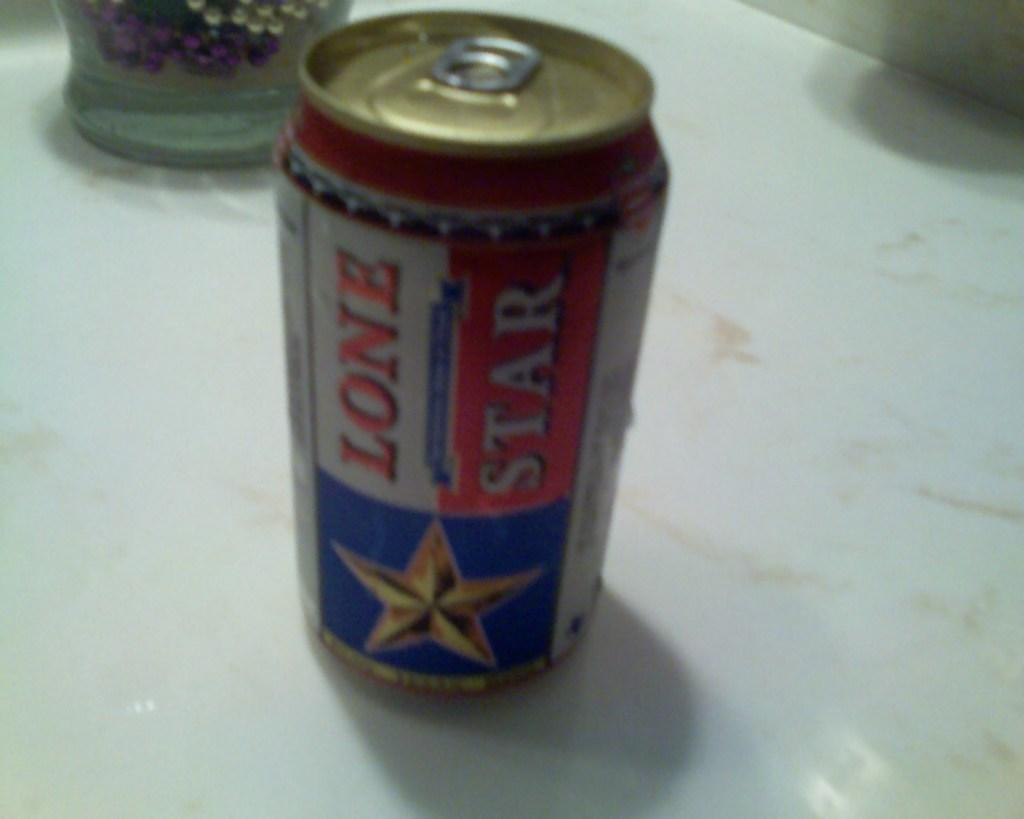<image>
Offer a succinct explanation of the picture presented. A lone star beer rests on a counter. 